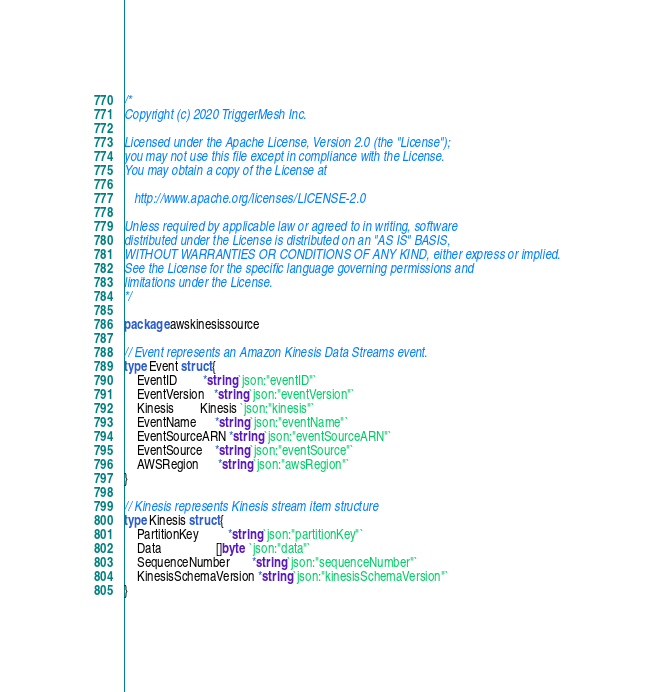<code> <loc_0><loc_0><loc_500><loc_500><_Go_>/*
Copyright (c) 2020 TriggerMesh Inc.

Licensed under the Apache License, Version 2.0 (the "License");
you may not use this file except in compliance with the License.
You may obtain a copy of the License at

   http://www.apache.org/licenses/LICENSE-2.0

Unless required by applicable law or agreed to in writing, software
distributed under the License is distributed on an "AS IS" BASIS,
WITHOUT WARRANTIES OR CONDITIONS OF ANY KIND, either express or implied.
See the License for the specific language governing permissions and
limitations under the License.
*/

package awskinesissource

// Event represents an Amazon Kinesis Data Streams event.
type Event struct {
	EventID        *string `json:"eventID"`
	EventVersion   *string `json:"eventVersion"`
	Kinesis        Kinesis `json:"kinesis"`
	EventName      *string `json:"eventName"`
	EventSourceARN *string `json:"eventSourceARN"`
	EventSource    *string `json:"eventSource"`
	AWSRegion      *string `json:"awsRegion"`
}

// Kinesis represents Kinesis stream item structure
type Kinesis struct {
	PartitionKey         *string `json:"partitionKey"`
	Data                 []byte  `json:"data"`
	SequenceNumber       *string `json:"sequenceNumber"`
	KinesisSchemaVersion *string `json:"kinesisSchemaVersion"`
}
</code> 